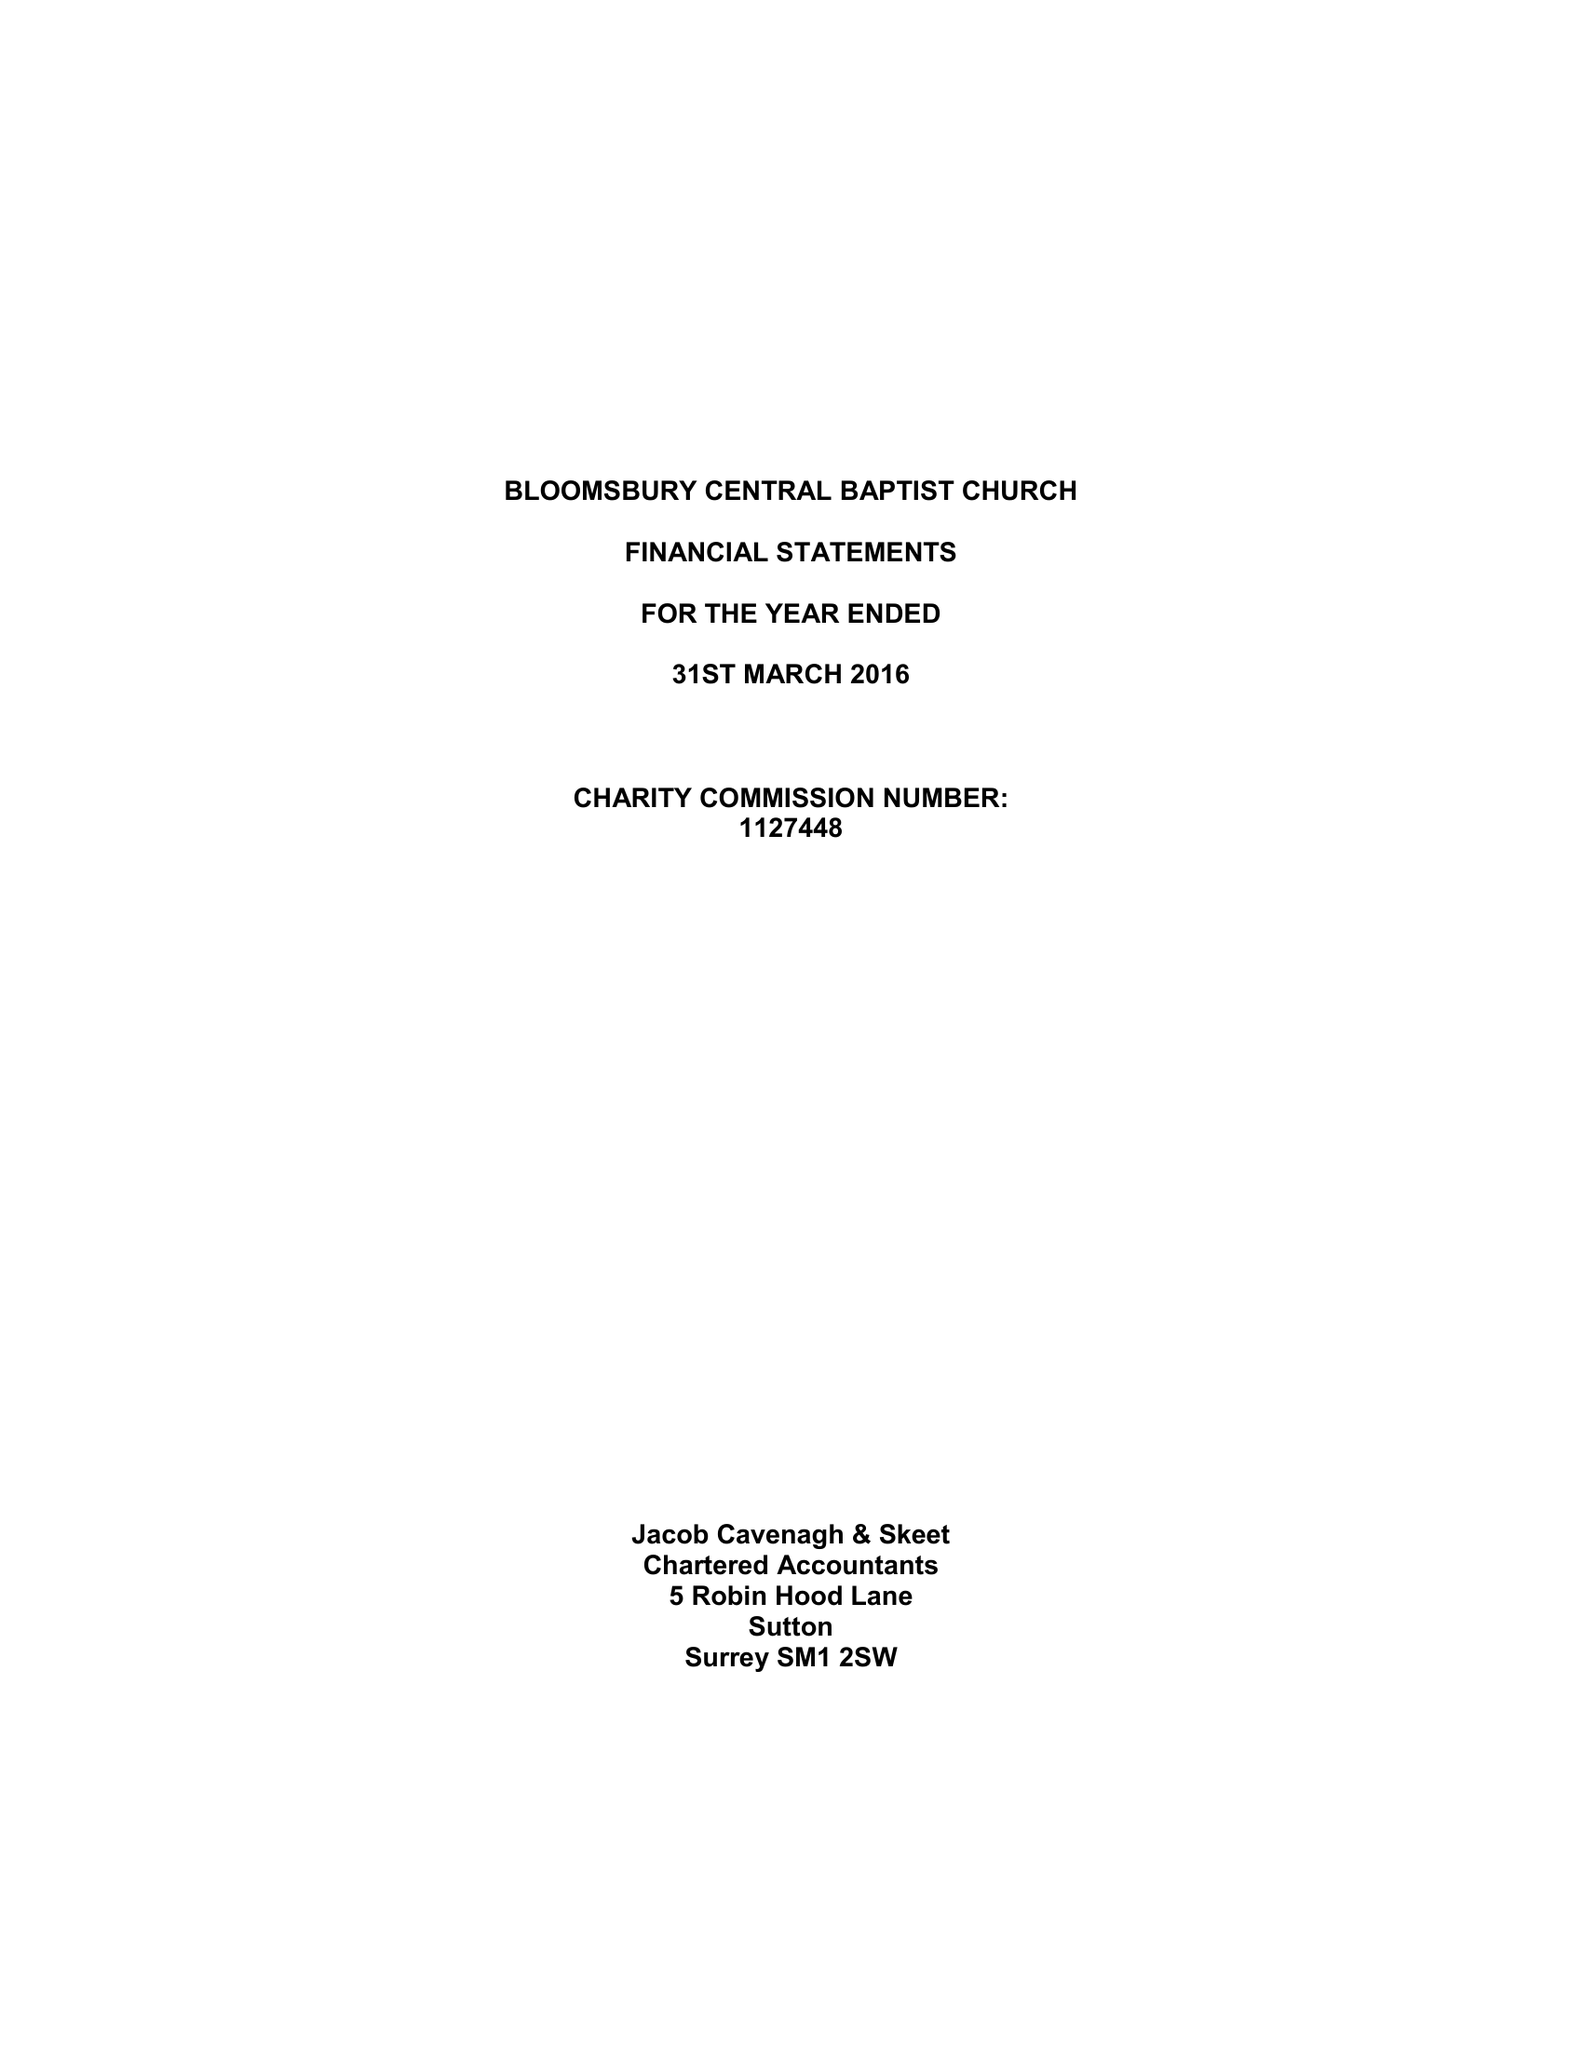What is the value for the charity_name?
Answer the question using a single word or phrase. Bloomsbury Central Baptist Church 